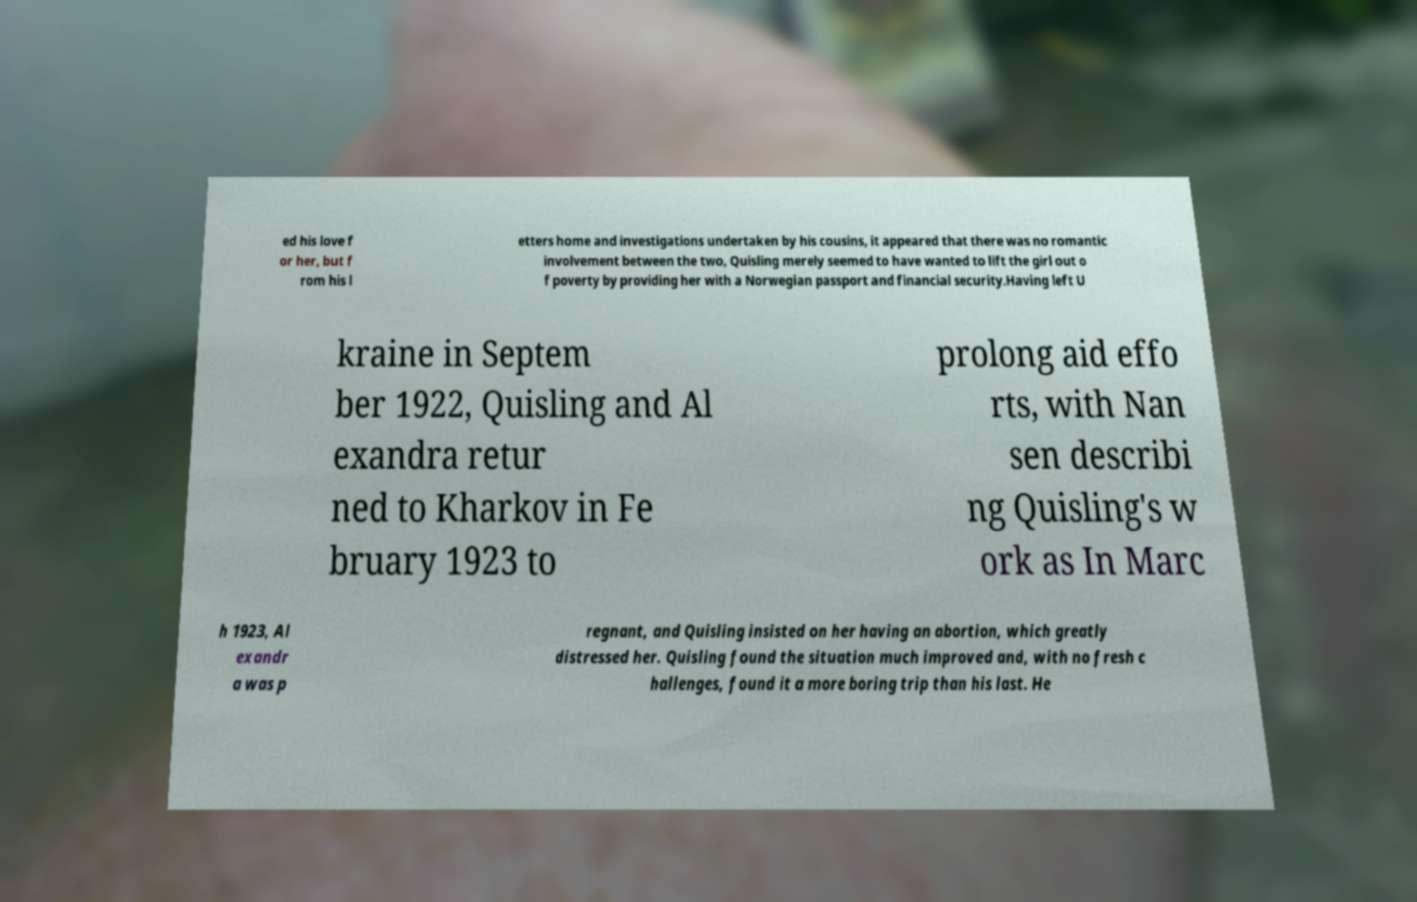Can you read and provide the text displayed in the image?This photo seems to have some interesting text. Can you extract and type it out for me? ed his love f or her, but f rom his l etters home and investigations undertaken by his cousins, it appeared that there was no romantic involvement between the two, Quisling merely seemed to have wanted to lift the girl out o f poverty by providing her with a Norwegian passport and financial security.Having left U kraine in Septem ber 1922, Quisling and Al exandra retur ned to Kharkov in Fe bruary 1923 to prolong aid effo rts, with Nan sen describi ng Quisling's w ork as In Marc h 1923, Al exandr a was p regnant, and Quisling insisted on her having an abortion, which greatly distressed her. Quisling found the situation much improved and, with no fresh c hallenges, found it a more boring trip than his last. He 